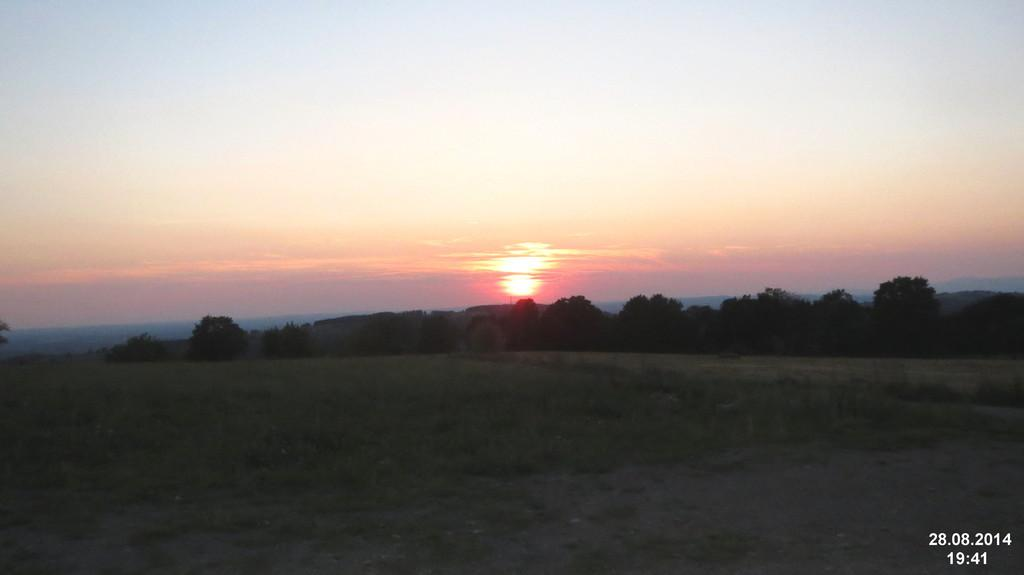What type of vegetation is present in the image? There are trees in the image. What color is the grass in the image? There is green grass in the image. What can be seen in the sky in the image? There are clouds visible in the sky. What type of street is visible in the image? There is no street present in the image; it features trees, green grass, and clouds in the sky. 